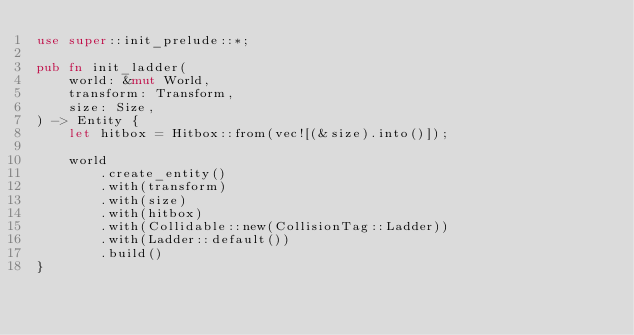Convert code to text. <code><loc_0><loc_0><loc_500><loc_500><_Rust_>use super::init_prelude::*;

pub fn init_ladder(
    world: &mut World,
    transform: Transform,
    size: Size,
) -> Entity {
    let hitbox = Hitbox::from(vec![(&size).into()]);

    world
        .create_entity()
        .with(transform)
        .with(size)
        .with(hitbox)
        .with(Collidable::new(CollisionTag::Ladder))
        .with(Ladder::default())
        .build()
}
</code> 